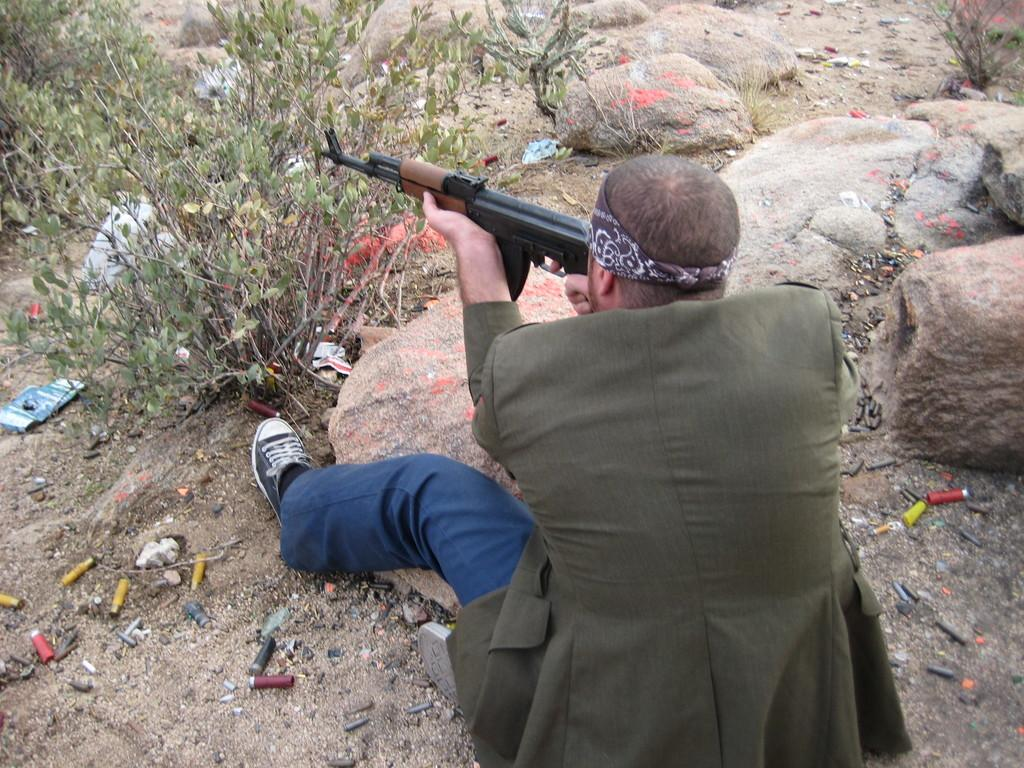What is the person in the image doing? The person is sitting on a surface and holding a gun. What can be seen in front of the person? There are plants and rocks in front of the person. What is on the surface where the person is sitting? There are objects on the surface. What type of plane can be seen flying in the image? There is no plane visible in the image. Can you describe the sock the person is wearing in the image? The person is not wearing a sock in the image. 